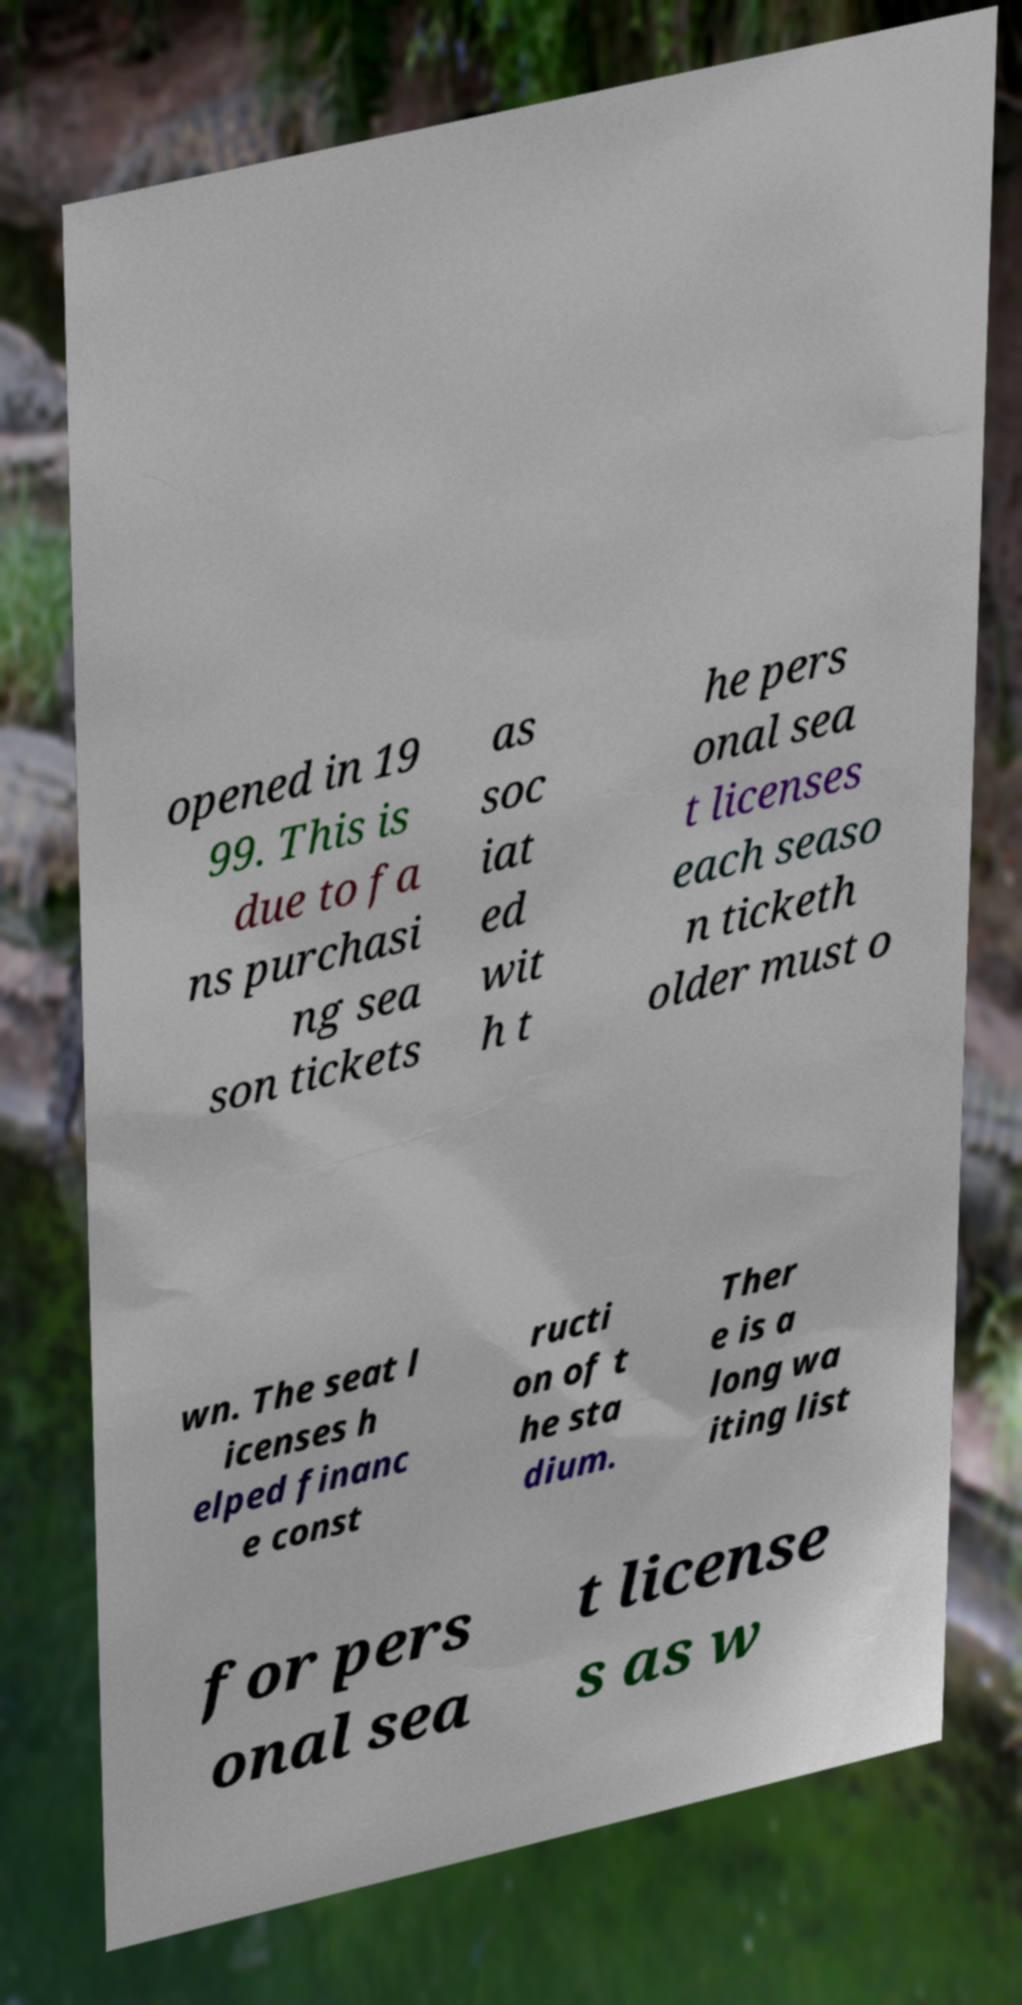Please read and relay the text visible in this image. What does it say? opened in 19 99. This is due to fa ns purchasi ng sea son tickets as soc iat ed wit h t he pers onal sea t licenses each seaso n ticketh older must o wn. The seat l icenses h elped financ e const ructi on of t he sta dium. Ther e is a long wa iting list for pers onal sea t license s as w 